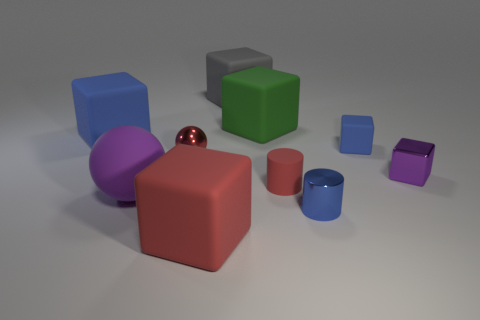Subtract all purple blocks. How many blocks are left? 5 Subtract all tiny purple metallic cubes. How many cubes are left? 5 Subtract all red blocks. Subtract all purple cylinders. How many blocks are left? 5 Subtract all cylinders. How many objects are left? 8 Subtract 0 brown blocks. How many objects are left? 10 Subtract all purple spheres. Subtract all big blue matte blocks. How many objects are left? 8 Add 1 small things. How many small things are left? 6 Add 7 small blue rubber objects. How many small blue rubber objects exist? 8 